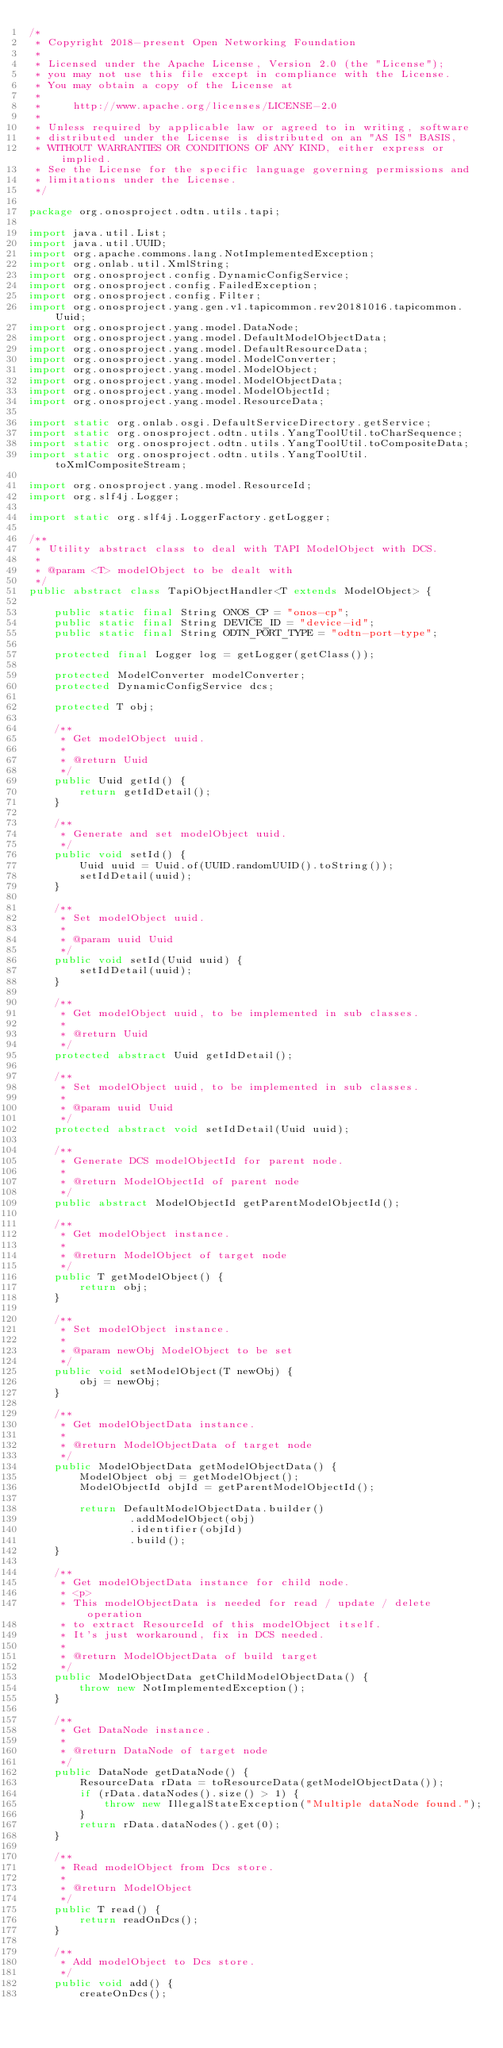Convert code to text. <code><loc_0><loc_0><loc_500><loc_500><_Java_>/*
 * Copyright 2018-present Open Networking Foundation
 *
 * Licensed under the Apache License, Version 2.0 (the "License");
 * you may not use this file except in compliance with the License.
 * You may obtain a copy of the License at
 *
 *     http://www.apache.org/licenses/LICENSE-2.0
 *
 * Unless required by applicable law or agreed to in writing, software
 * distributed under the License is distributed on an "AS IS" BASIS,
 * WITHOUT WARRANTIES OR CONDITIONS OF ANY KIND, either express or implied.
 * See the License for the specific language governing permissions and
 * limitations under the License.
 */

package org.onosproject.odtn.utils.tapi;

import java.util.List;
import java.util.UUID;
import org.apache.commons.lang.NotImplementedException;
import org.onlab.util.XmlString;
import org.onosproject.config.DynamicConfigService;
import org.onosproject.config.FailedException;
import org.onosproject.config.Filter;
import org.onosproject.yang.gen.v1.tapicommon.rev20181016.tapicommon.Uuid;
import org.onosproject.yang.model.DataNode;
import org.onosproject.yang.model.DefaultModelObjectData;
import org.onosproject.yang.model.DefaultResourceData;
import org.onosproject.yang.model.ModelConverter;
import org.onosproject.yang.model.ModelObject;
import org.onosproject.yang.model.ModelObjectData;
import org.onosproject.yang.model.ModelObjectId;
import org.onosproject.yang.model.ResourceData;

import static org.onlab.osgi.DefaultServiceDirectory.getService;
import static org.onosproject.odtn.utils.YangToolUtil.toCharSequence;
import static org.onosproject.odtn.utils.YangToolUtil.toCompositeData;
import static org.onosproject.odtn.utils.YangToolUtil.toXmlCompositeStream;

import org.onosproject.yang.model.ResourceId;
import org.slf4j.Logger;

import static org.slf4j.LoggerFactory.getLogger;

/**
 * Utility abstract class to deal with TAPI ModelObject with DCS.
 *
 * @param <T> modelObject to be dealt with
 */
public abstract class TapiObjectHandler<T extends ModelObject> {

    public static final String ONOS_CP = "onos-cp";
    public static final String DEVICE_ID = "device-id";
    public static final String ODTN_PORT_TYPE = "odtn-port-type";

    protected final Logger log = getLogger(getClass());

    protected ModelConverter modelConverter;
    protected DynamicConfigService dcs;

    protected T obj;

    /**
     * Get modelObject uuid.
     *
     * @return Uuid
     */
    public Uuid getId() {
        return getIdDetail();
    }

    /**
     * Generate and set modelObject uuid.
     */
    public void setId() {
        Uuid uuid = Uuid.of(UUID.randomUUID().toString());
        setIdDetail(uuid);
    }

    /**
     * Set modelObject uuid.
     *
     * @param uuid Uuid
     */
    public void setId(Uuid uuid) {
        setIdDetail(uuid);
    }

    /**
     * Get modelObject uuid, to be implemented in sub classes.
     *
     * @return Uuid
     */
    protected abstract Uuid getIdDetail();

    /**
     * Set modelObject uuid, to be implemented in sub classes.
     *
     * @param uuid Uuid
     */
    protected abstract void setIdDetail(Uuid uuid);

    /**
     * Generate DCS modelObjectId for parent node.
     *
     * @return ModelObjectId of parent node
     */
    public abstract ModelObjectId getParentModelObjectId();

    /**
     * Get modelObject instance.
     *
     * @return ModelObject of target node
     */
    public T getModelObject() {
        return obj;
    }

    /**
     * Set modelObject instance.
     *
     * @param newObj ModelObject to be set
     */
    public void setModelObject(T newObj) {
        obj = newObj;
    }

    /**
     * Get modelObjectData instance.
     *
     * @return ModelObjectData of target node
     */
    public ModelObjectData getModelObjectData() {
        ModelObject obj = getModelObject();
        ModelObjectId objId = getParentModelObjectId();

        return DefaultModelObjectData.builder()
                .addModelObject(obj)
                .identifier(objId)
                .build();
    }

    /**
     * Get modelObjectData instance for child node.
     * <p>
     * This modelObjectData is needed for read / update / delete operation
     * to extract ResourceId of this modelObject itself.
     * It's just workaround, fix in DCS needed.
     *
     * @return ModelObjectData of build target
     */
    public ModelObjectData getChildModelObjectData() {
        throw new NotImplementedException();
    }

    /**
     * Get DataNode instance.
     *
     * @return DataNode of target node
     */
    public DataNode getDataNode() {
        ResourceData rData = toResourceData(getModelObjectData());
        if (rData.dataNodes().size() > 1) {
            throw new IllegalStateException("Multiple dataNode found.");
        }
        return rData.dataNodes().get(0);
    }

    /**
     * Read modelObject from Dcs store.
     *
     * @return ModelObject
     */
    public T read() {
        return readOnDcs();
    }

    /**
     * Add modelObject to Dcs store.
     */
    public void add() {
        createOnDcs();</code> 